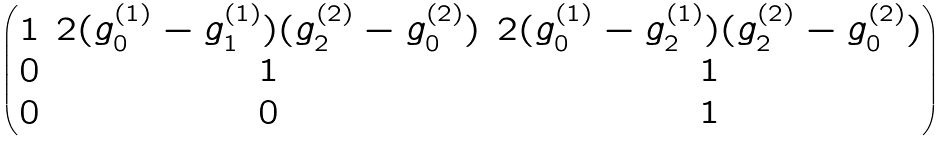<formula> <loc_0><loc_0><loc_500><loc_500>\begin{pmatrix} 1 & 2 ( g _ { 0 } ^ { ( 1 ) } - g _ { 1 } ^ { ( 1 ) } ) ( g _ { 2 } ^ { ( 2 ) } - g _ { 0 } ^ { ( 2 ) } ) & 2 ( g _ { 0 } ^ { ( 1 ) } - g _ { 2 } ^ { ( 1 ) } ) ( g _ { 2 } ^ { ( 2 ) } - g _ { 0 } ^ { ( 2 ) } ) \\ 0 & 1 & 1 \\ 0 & 0 & 1 \end{pmatrix}</formula> 